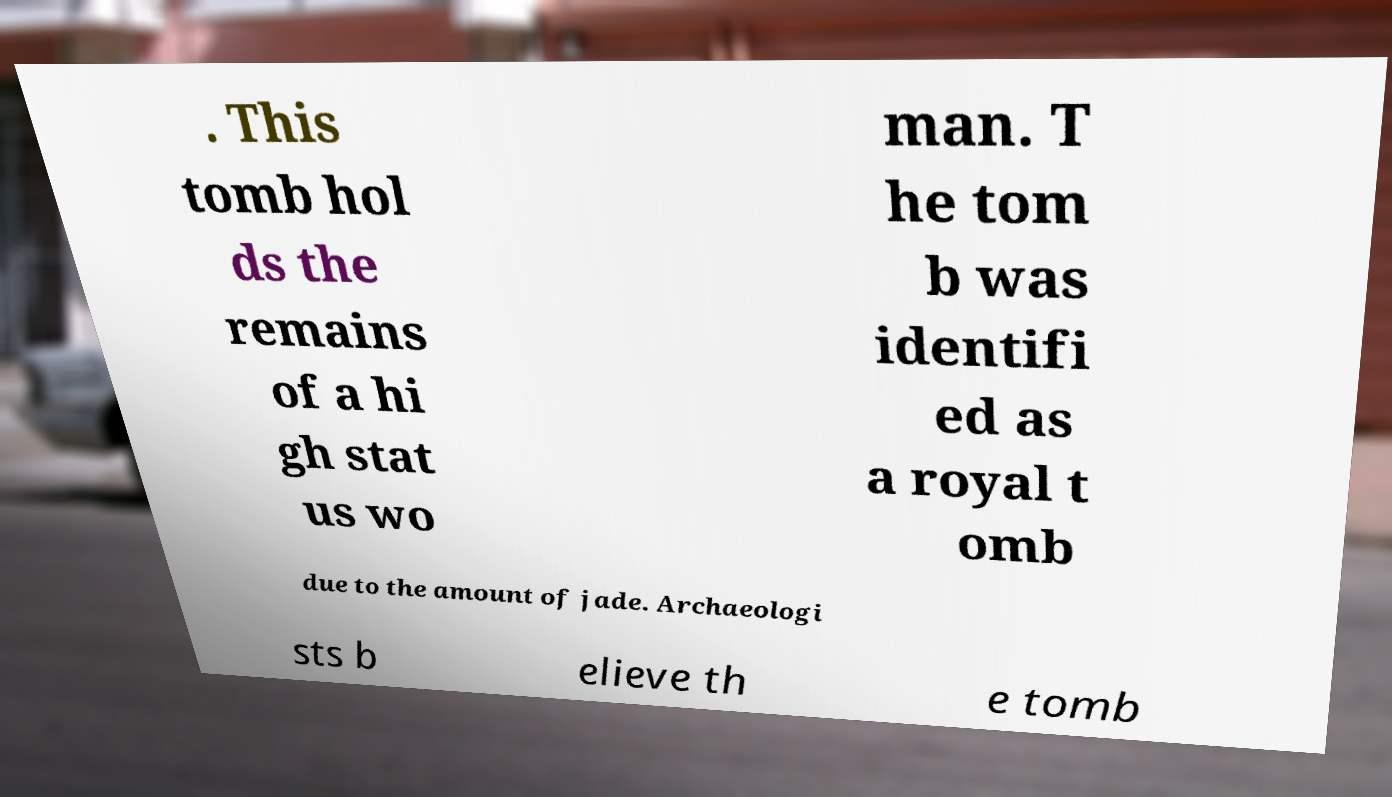For documentation purposes, I need the text within this image transcribed. Could you provide that? . This tomb hol ds the remains of a hi gh stat us wo man. T he tom b was identifi ed as a royal t omb due to the amount of jade. Archaeologi sts b elieve th e tomb 